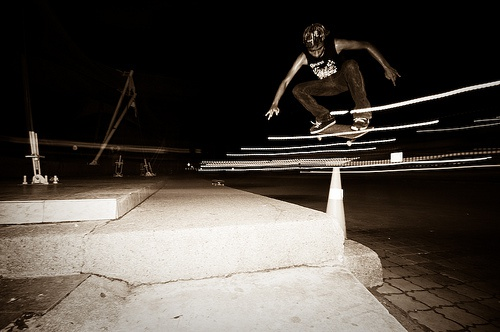Describe the objects in this image and their specific colors. I can see people in black, maroon, and gray tones and skateboard in black, white, maroon, and gray tones in this image. 